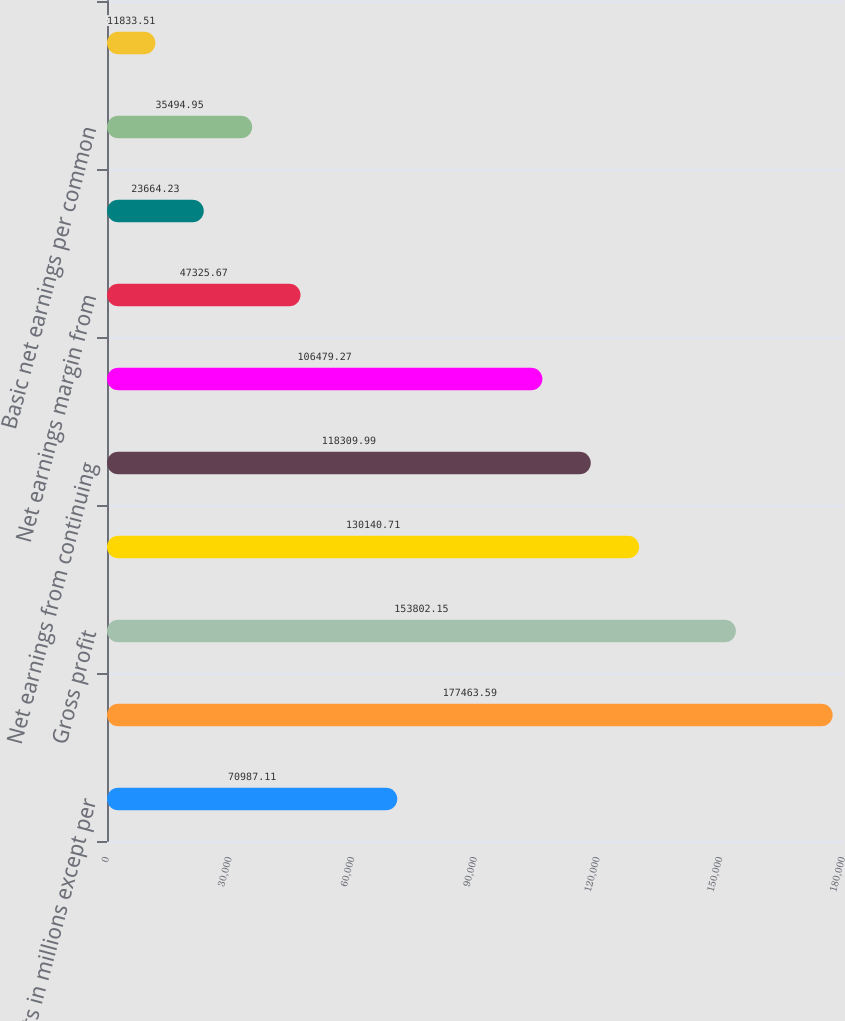Convert chart. <chart><loc_0><loc_0><loc_500><loc_500><bar_chart><fcel>Amounts in millions except per<fcel>Net sales<fcel>Gross profit<fcel>Operating income<fcel>Net earnings from continuing<fcel>Net earnings attributable to<fcel>Net earnings margin from<fcel>Earnings from continuing<fcel>Basic net earnings per common<fcel>Diluted net earnings per<nl><fcel>70987.1<fcel>177464<fcel>153802<fcel>130141<fcel>118310<fcel>106479<fcel>47325.7<fcel>23664.2<fcel>35494.9<fcel>11833.5<nl></chart> 